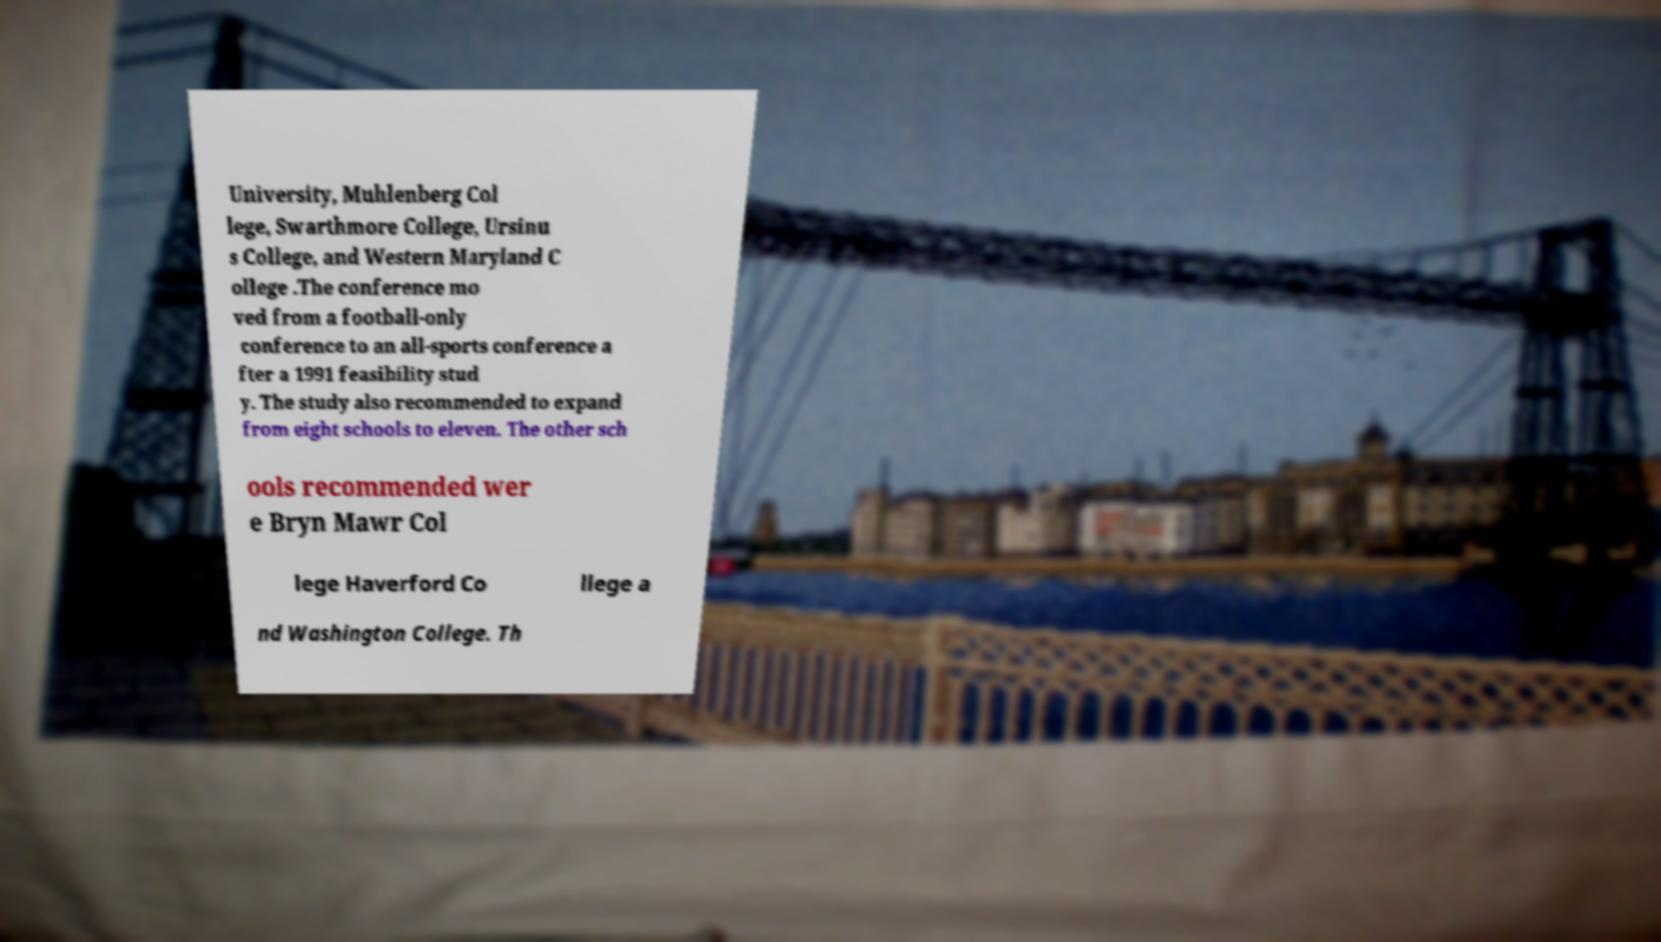I need the written content from this picture converted into text. Can you do that? University, Muhlenberg Col lege, Swarthmore College, Ursinu s College, and Western Maryland C ollege .The conference mo ved from a football-only conference to an all-sports conference a fter a 1991 feasibility stud y. The study also recommended to expand from eight schools to eleven. The other sch ools recommended wer e Bryn Mawr Col lege Haverford Co llege a nd Washington College. Th 